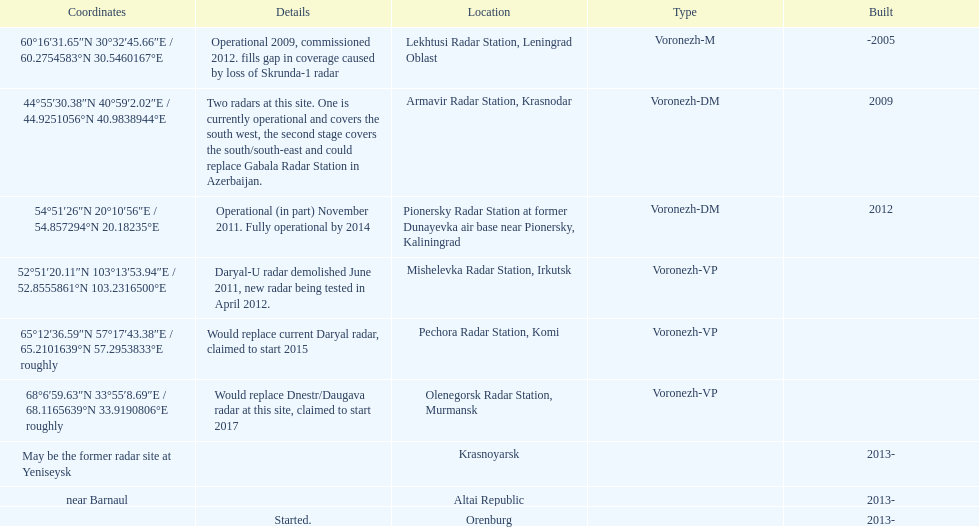What is the only location with a coordination of 60°16&#8242;31.65&#8243;n 30°32&#8242;45.66&#8243;e / 60.2754583°n 30.5460167°e? Lekhtusi Radar Station, Leningrad Oblast. 